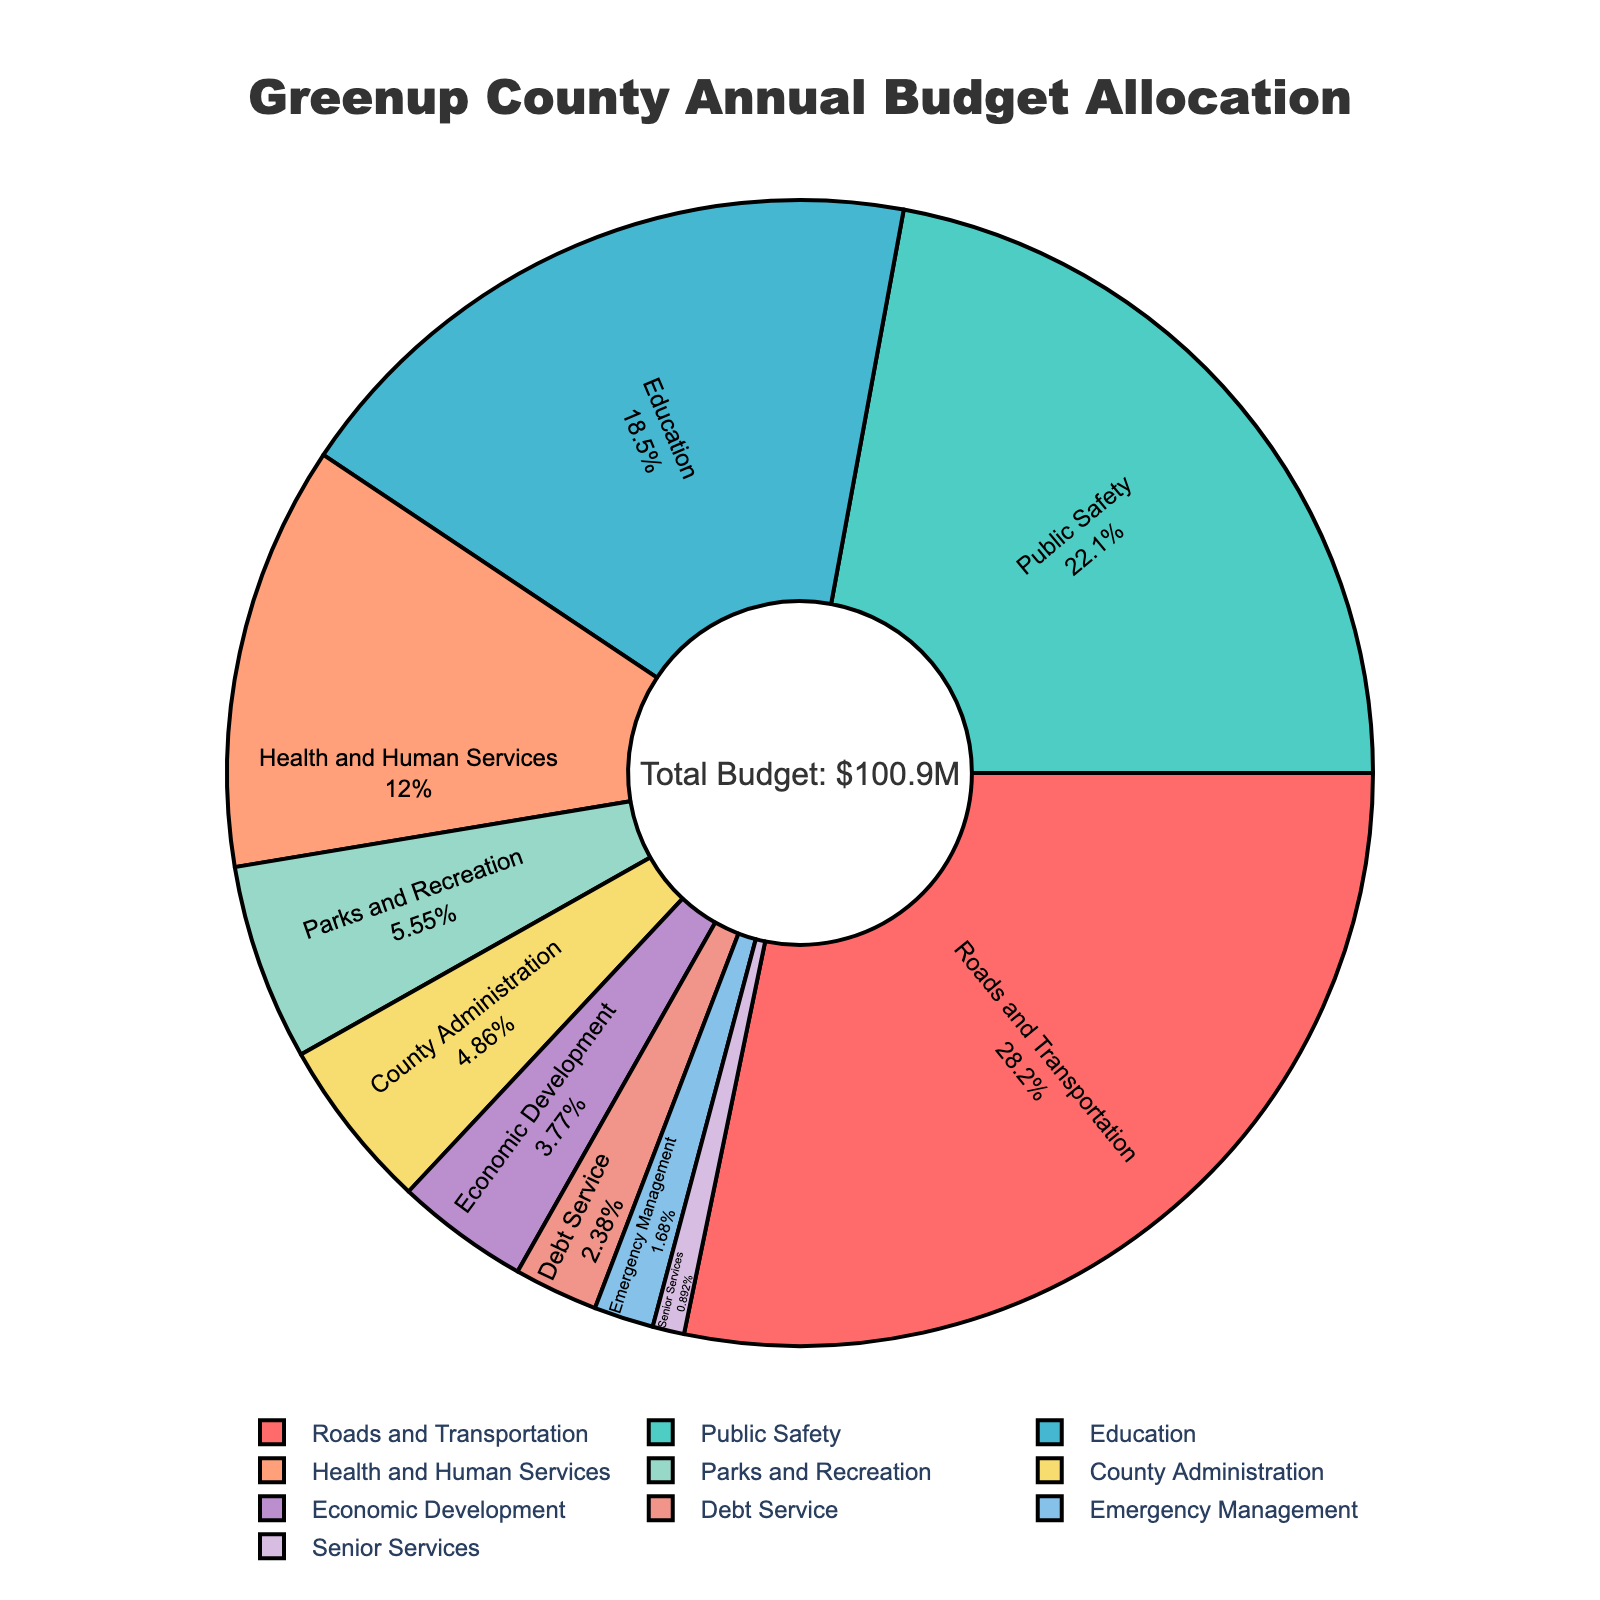What is the highest budget allocation percentage? To determine the highest budget allocation percentage, look at the slices of the pie chart and identify the largest one. The largest slice represents "Roads and Transportation" with 28.5%.
Answer: Roads and Transportation with 28.5% Which department has a higher budget allocation: Health and Human Services or Parks and Recreation? Compare the slices for "Health and Human Services" and "Parks and Recreation". "Health and Human Services" has 12.1%, while "Parks and Recreation" has 5.6%, so "Health and Human Services" is higher.
Answer: Health and Human Services What is the combined budget percentage for Education, Health and Human Services, and County Administration? Add the percentages for Education (18.7%), Health and Human Services (12.1%), and County Administration (4.9%): 18.7 + 12.1 + 4.9 = 35.7%.
Answer: 35.7% How much larger is the budget allocation for Public Safety compared to Economic Development? Subtract the percentage for Economic Development (3.8%) from Public Safety (22.3%): 22.3 - 3.8 = 18.5%.
Answer: 18.5% Identify the color representing the Parks and Recreation department. Look at the slice labeled "Parks and Recreation" and note its color, which is green.
Answer: Green What percentage of the budget is allocated to departments other than Roads and Transportation and Public Safety? Subtract the combined percentage of Roads and Transportation (28.5%) and Public Safety (22.3%) from 100%: 100 - (28.5 + 22.3) = 49.2%.
Answer: 49.2% Calculate the average budget allocation for Senior Services, Emergency Management, and Debt Service. Add the percentages for Senior Services (0.9%), Emergency Management (1.7%), and Debt Service (2.4%) and divide by 3: (0.9 + 1.7 + 2.4)/3 = 1.67%.
Answer: 1.67% What department has the smallest budget allocation and what is its percentage? Identify the smallest slice which represents "Senior Services" with 0.9%.
Answer: Senior Services with 0.9% What fraction of the budget is spent on Parks and Recreation compared to Education? Divide the percentage of Parks and Recreation (5.6%) by that of Education (18.7%): 5.6 / 18.7 ≈ 0.30.
Answer: Approximately 0.30 How many departments have a budget allocation less than 5%? Count the slices with a percentage less than 5%: County Administration (4.9%), Economic Development (3.8%), Debt Service (2.4%), Emergency Management (1.7%), and Senior Services (0.9%), making it 5 departments.
Answer: 5 